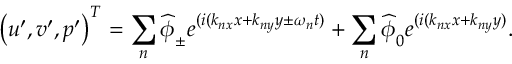<formula> <loc_0><loc_0><loc_500><loc_500>\left ( u ^ { \prime } , v ^ { \prime } , p ^ { \prime } \right ) ^ { T } = \sum _ { n } \widehat { \phi } _ { \pm } e ^ { ( i ( k _ { n x } x + k _ { n y } y \pm \omega _ { n } t ) } + \sum _ { n } \widehat { \phi } _ { 0 } e ^ { ( i ( k _ { n x } x + k _ { n y } y ) } .</formula> 